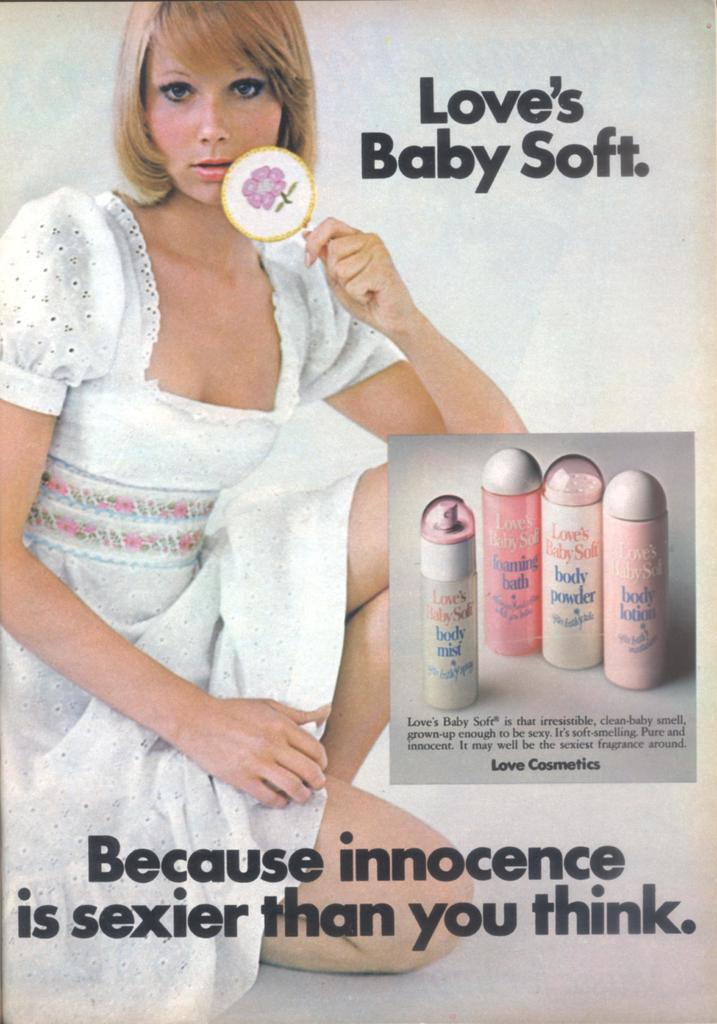How has the image been altered or modified? The image is edited. What can be found written on the image? There are texts written on the image. Can you describe the person in the image? There is a woman sitting in the image. What advice does the woman in the image give to the viewer? There is no indication in the image that the woman is giving advice to the viewer. 